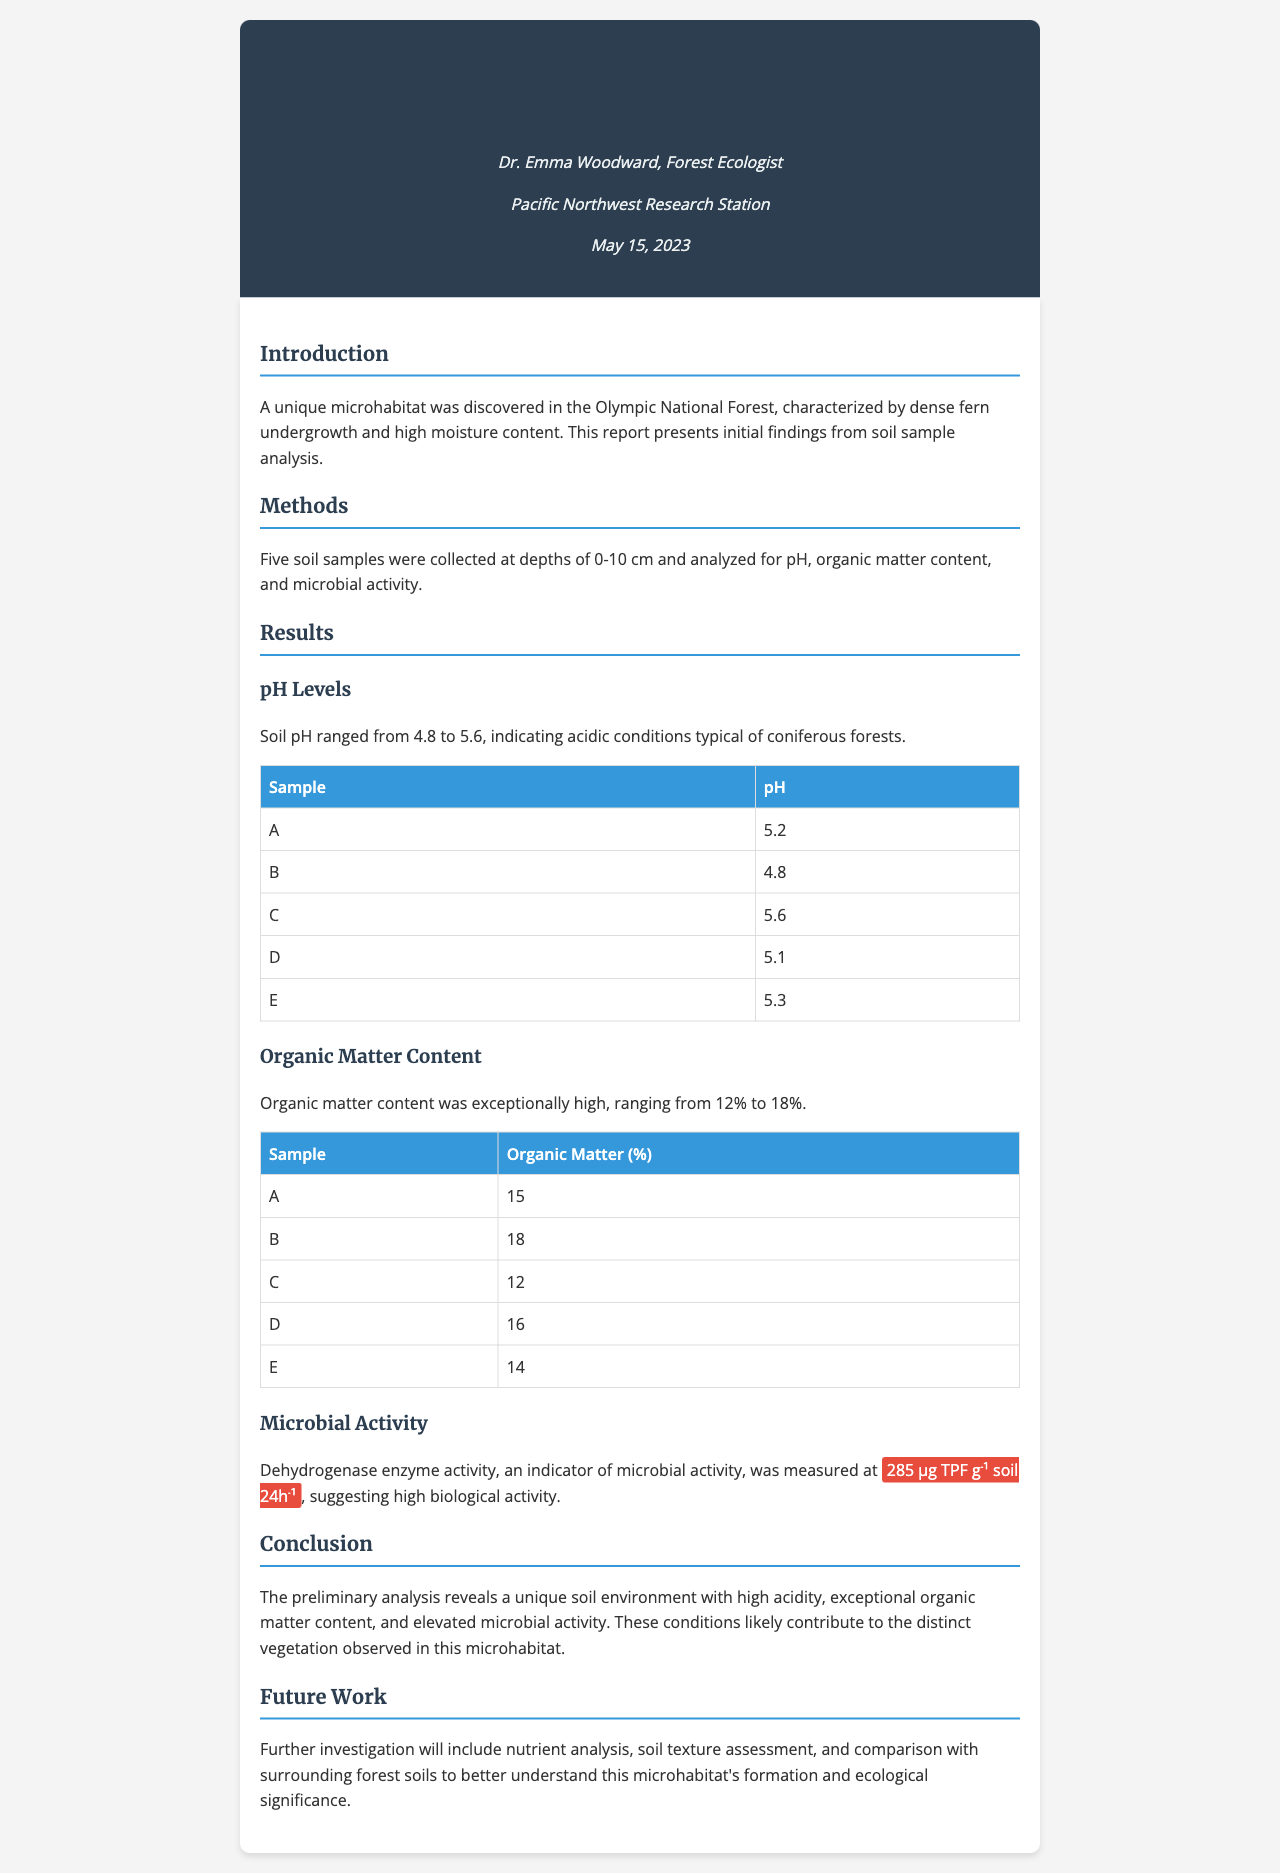What is the title of the document? The title is presented prominently at the top of the document, which highlights its contents.
Answer: Preliminary Analysis of Soil Samples from Newly Discovered Forest Microhabitat Who is the author of the report? The document lists the author's name in the header section, providing credit for the findings.
Answer: Dr. Emma Woodward What is the range of soil pH levels reported? The document specifies the range of pH levels found in the soil samples, which indicates the acidity.
Answer: 4.8 to 5.6 What was the highest organic matter content found in the samples? The table under "Organic Matter Content" indicates the highest percentage of organic matter measured.
Answer: 18 What does the indicated value of microbial activity suggest? The document mentions that the measured activity indicates a level of biological activity in the soil, reflecting its health.
Answer: High biological activity What is the next step in the research according to the "Future Work" section? The future work section outlines additional investigations that will deepen understanding of the microhabitat.
Answer: Nutrient analysis What ecological feature characterizes the discovered microhabitat? The introduction describes a defining characteristic of the microhabitat that informs about its environment.
Answer: Dense fern undergrowth What enzyme activity was measured to assess microbial activity? The results section specifies the type of enzyme used as an indicator for measuring microbial activity in the soil.
Answer: Dehydrogenase enzyme activity 